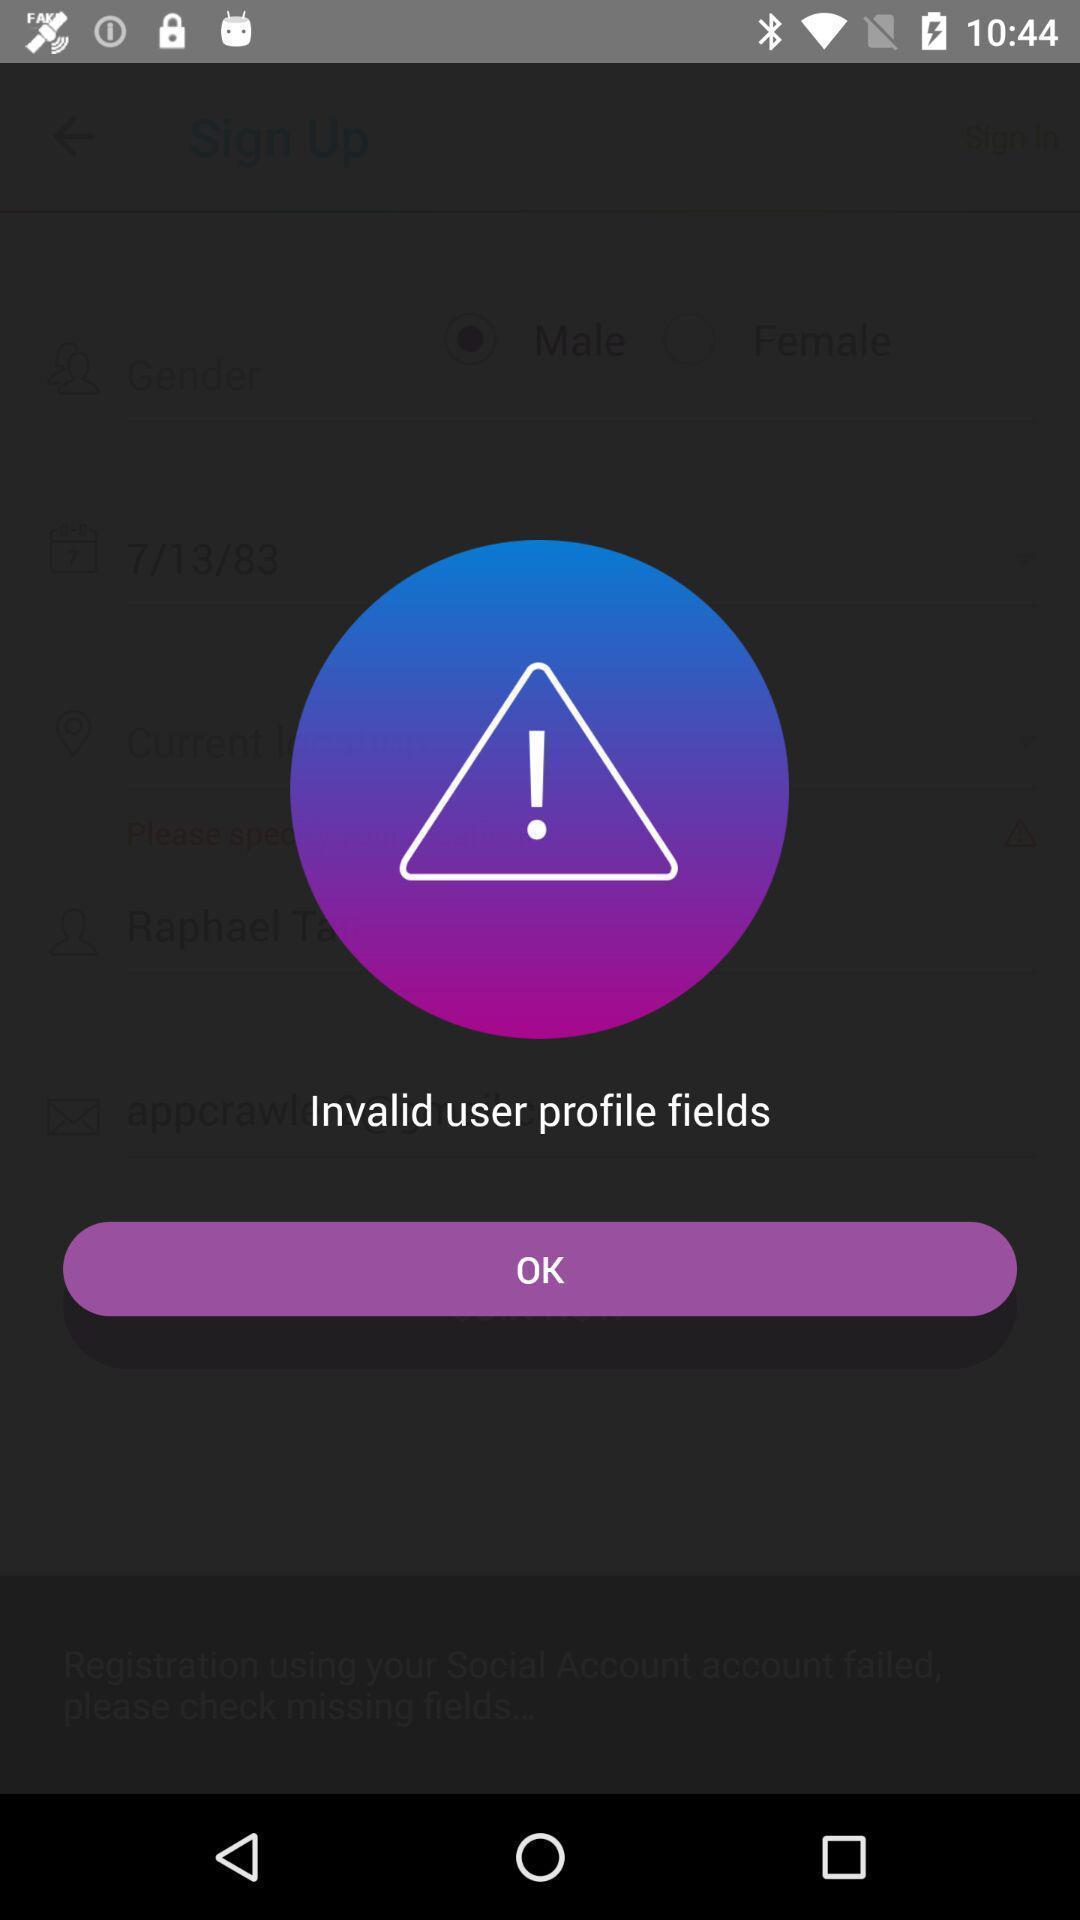Provide a detailed account of this screenshot. Pop-up screen displaying with invalid user profile. 